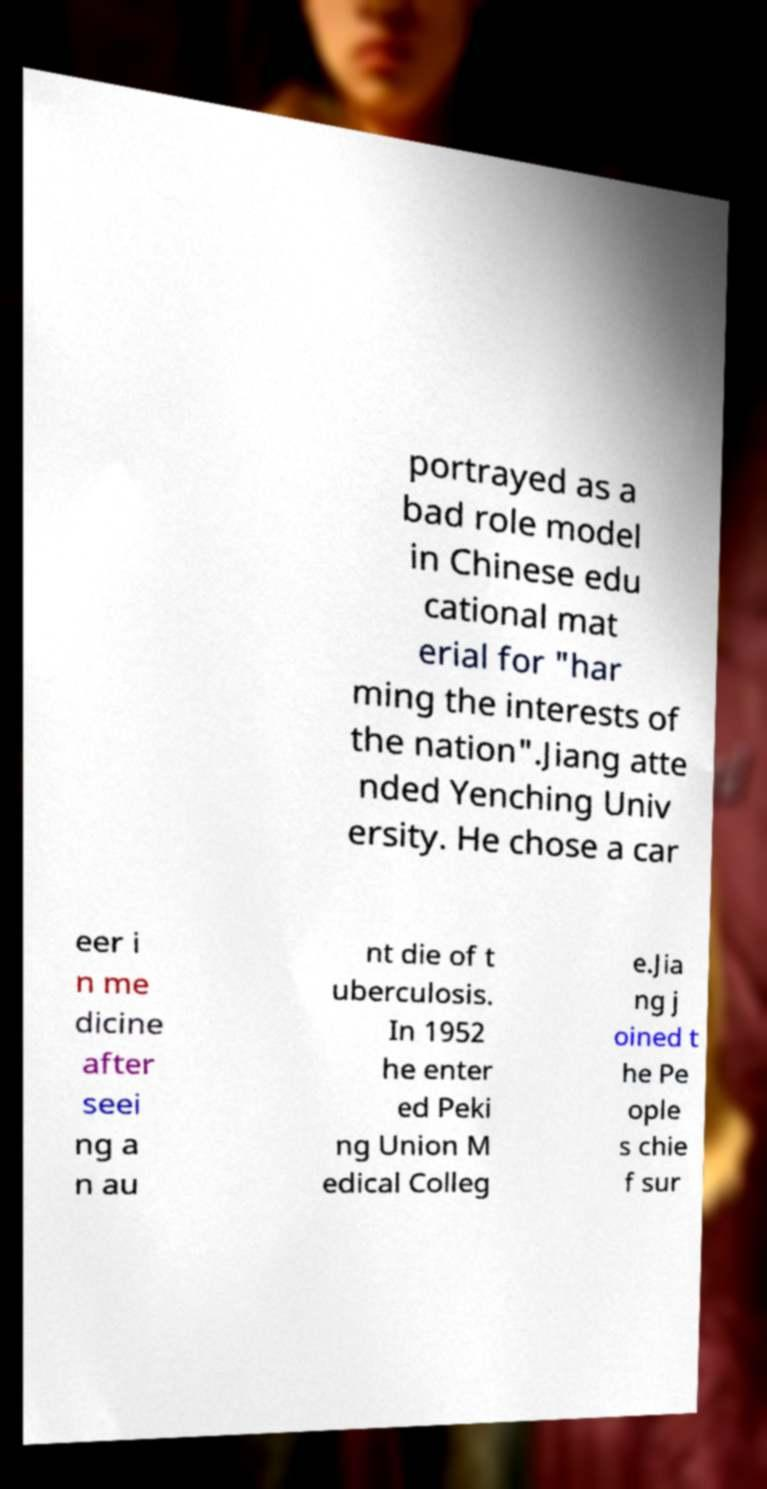Could you extract and type out the text from this image? portrayed as a bad role model in Chinese edu cational mat erial for "har ming the interests of the nation".Jiang atte nded Yenching Univ ersity. He chose a car eer i n me dicine after seei ng a n au nt die of t uberculosis. In 1952 he enter ed Peki ng Union M edical Colleg e.Jia ng j oined t he Pe ople s chie f sur 